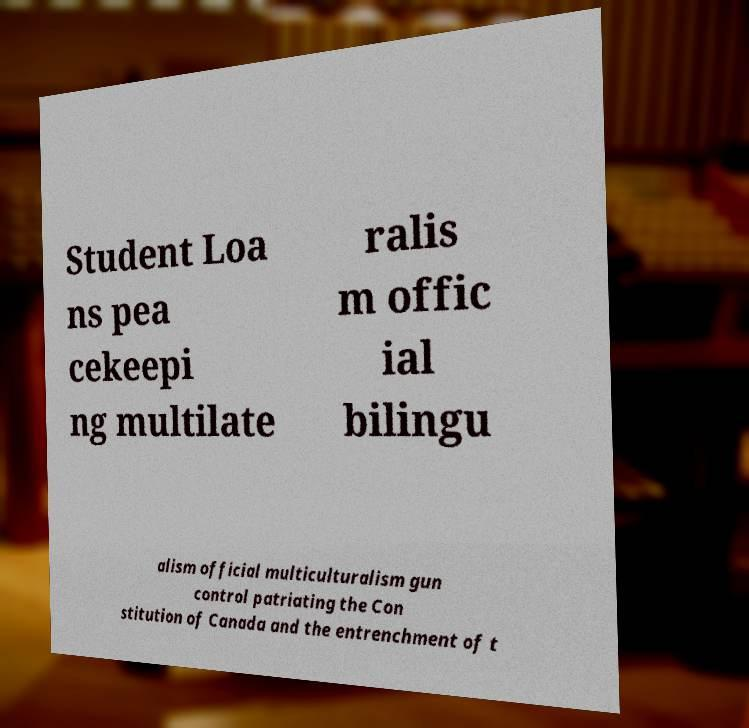Could you assist in decoding the text presented in this image and type it out clearly? Student Loa ns pea cekeepi ng multilate ralis m offic ial bilingu alism official multiculturalism gun control patriating the Con stitution of Canada and the entrenchment of t 